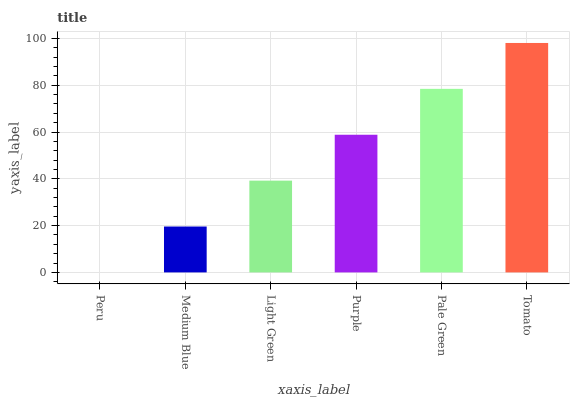Is Medium Blue the minimum?
Answer yes or no. No. Is Medium Blue the maximum?
Answer yes or no. No. Is Medium Blue greater than Peru?
Answer yes or no. Yes. Is Peru less than Medium Blue?
Answer yes or no. Yes. Is Peru greater than Medium Blue?
Answer yes or no. No. Is Medium Blue less than Peru?
Answer yes or no. No. Is Purple the high median?
Answer yes or no. Yes. Is Light Green the low median?
Answer yes or no. Yes. Is Light Green the high median?
Answer yes or no. No. Is Medium Blue the low median?
Answer yes or no. No. 